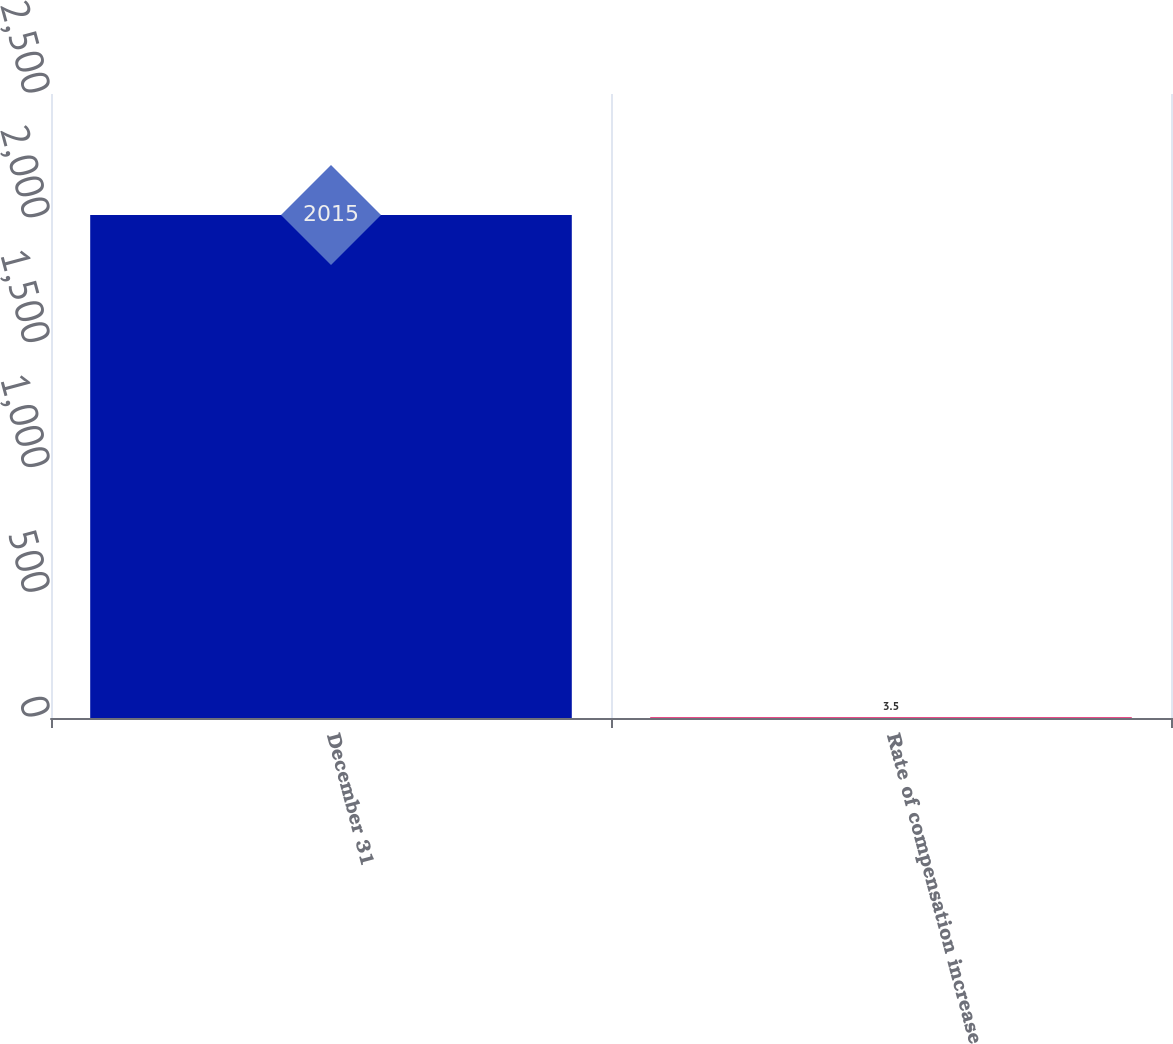Convert chart to OTSL. <chart><loc_0><loc_0><loc_500><loc_500><bar_chart><fcel>December 31<fcel>Rate of compensation increase<nl><fcel>2015<fcel>3.5<nl></chart> 